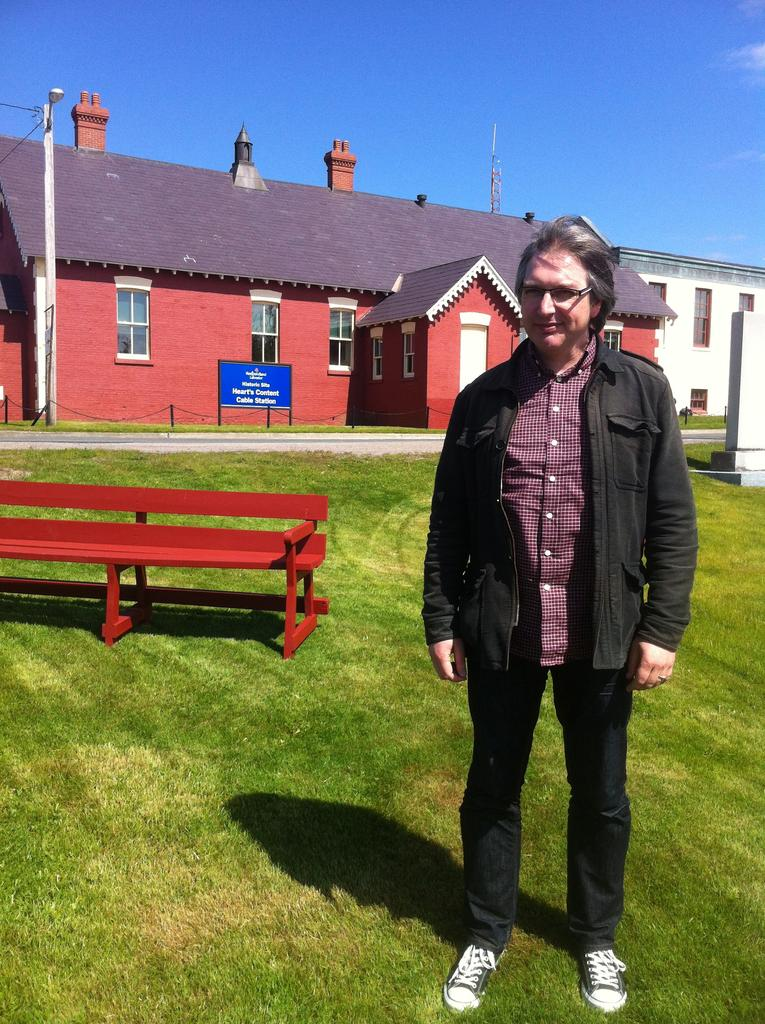What is the main subject of the picture? The main subject of the picture is a man. Can you describe the man's appearance? The man is wearing spectacles and a jacket. Where is the man standing? The man is standing on grass. What can be seen in the background of the image? There is a bench, a house with windows, a banner, the sky, and a pole in the background of the image. How many fairies are sitting on the bench in the background of the image? There are no fairies present in the image. Can you tell me how many babies are visible in the man's jacket? There are no babies visible in the man's jacket. 